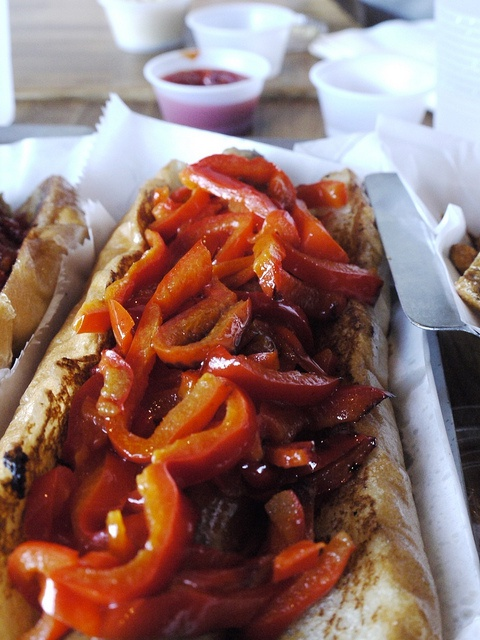Describe the objects in this image and their specific colors. I can see sandwich in white, maroon, black, and brown tones, hot dog in white, maroon, black, and brown tones, hot dog in white, brown, gray, darkgray, and tan tones, and bowl in white, lavender, violet, and darkgray tones in this image. 